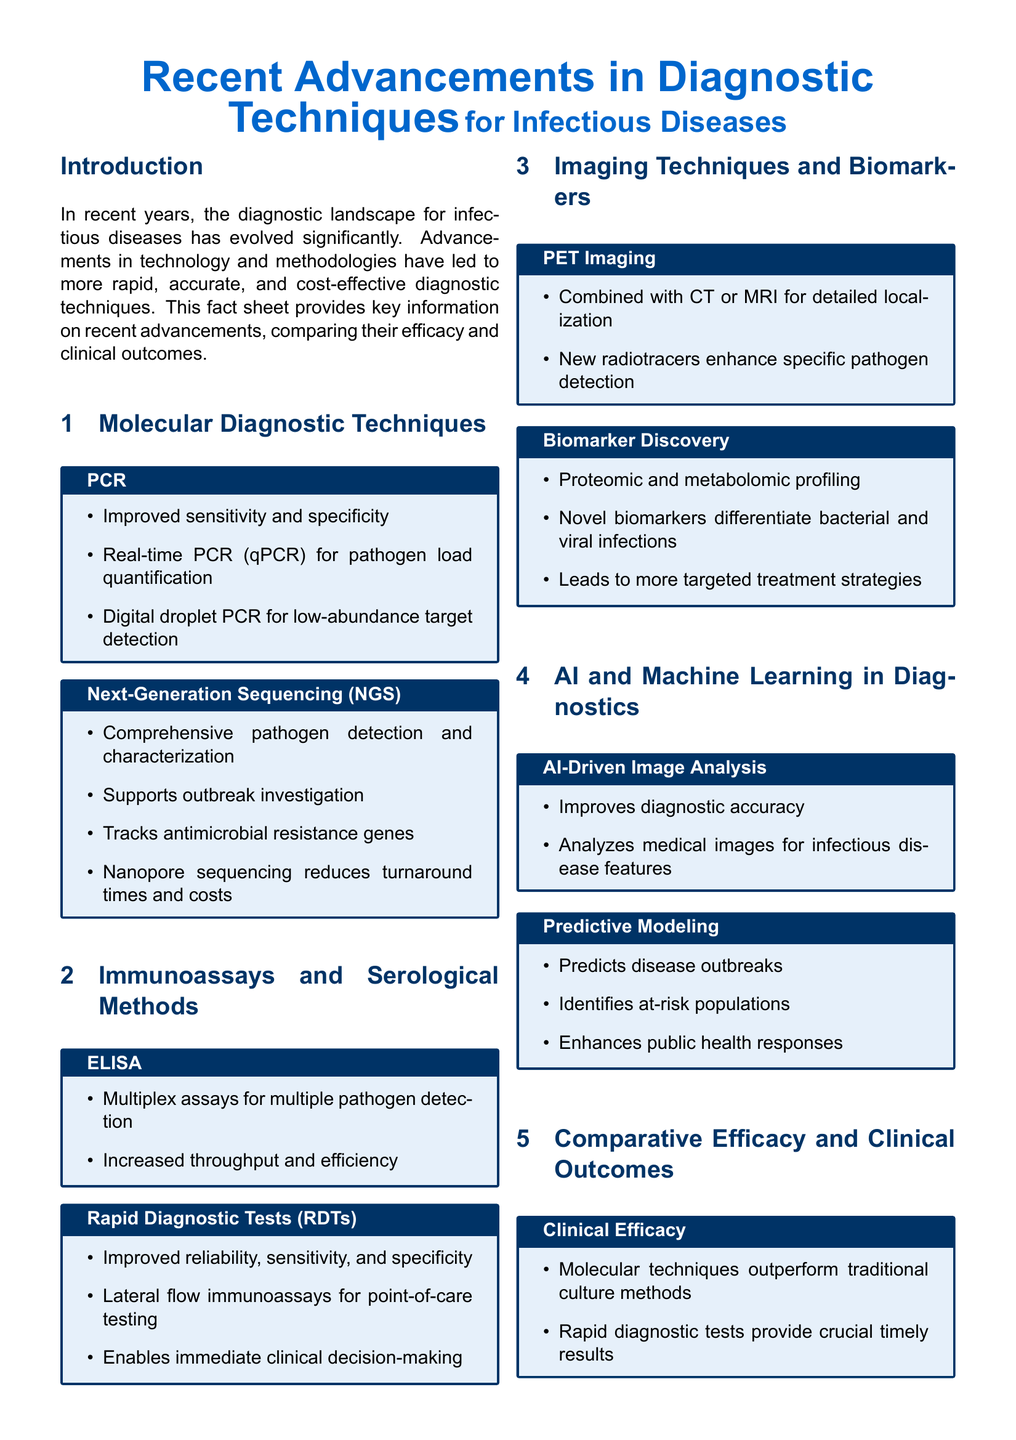what technique quantifies pathogen load? Real-time PCR (qPCR) is mentioned as a method for pathogen load quantification, indicating its specific functionality within molecular diagnostics.
Answer: Real-time PCR (qPCR) what advantage does Next-Generation Sequencing provide for outbreak investigation? The document states that Next-Generation Sequencing supports outbreak investigation, highlighting its role in public health.
Answer: Supports outbreak investigation which immunoassay method offers multiplex capabilities? ELISA is noted for its multiplex assays, indicating its ability to detect multiple pathogens simultaneously.
Answer: ELISA what is the main benefit of Rapid Diagnostic Tests? The document emphasizes that RDTs enable immediate clinical decision-making, showcasing their timely application in patient care.
Answer: Immediate clinical decision-making what advanced technique is used for diagnosing infectious disease features in images? AI-Driven Image Analysis improves diagnostic accuracy by analyzing medical images for infectious disease features, illustrating the integration of technology in diagnostics.
Answer: AI-Driven Image Analysis what improves patient outcomes according to the fact sheet? The document emphasizes that earlier and more accurate treatment leads to improved patient outcomes, particularly crucial in infection management.
Answer: Earlier and more accurate treatment which method is more effective than traditional culture methods? The fact sheet indicates that molecular techniques outperform traditional culture methods in terms of clinical efficacy.
Answer: Molecular techniques what is a key discovery area for differentiating infections? Biomarkers discovered through proteomic and metabolomic profiling enable differentiation between bacterial and viral infections, highlighting a crucial area of advancement.
Answer: Biomarker Discovery how does predictive modeling enhance public health? Predictive modeling identifies at-risk populations, thus enhancing public health responses, indicating its significance in disease prevention strategies.
Answer: Identifies at-risk populations 